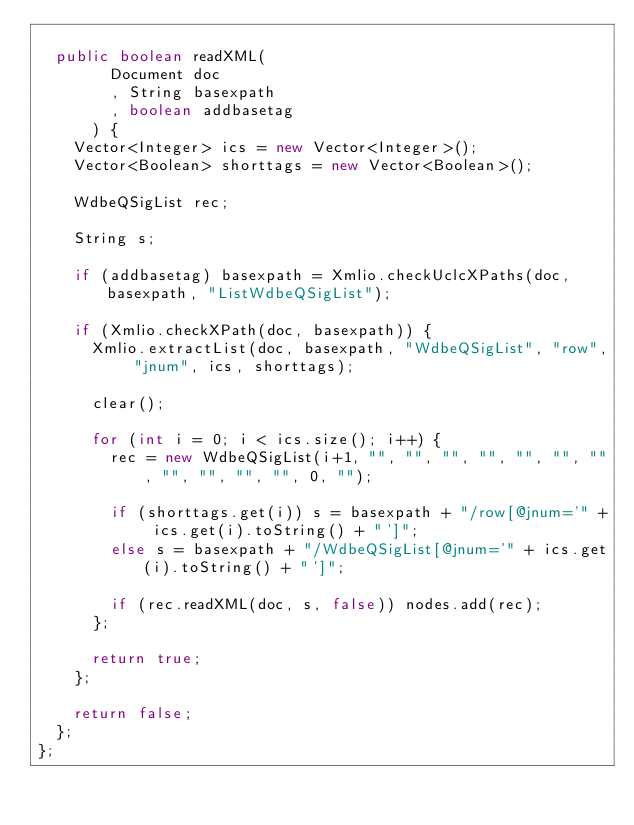Convert code to text. <code><loc_0><loc_0><loc_500><loc_500><_Java_>
	public boolean readXML(
				Document doc
				, String basexpath
				, boolean addbasetag
			) {
		Vector<Integer> ics = new Vector<Integer>();
		Vector<Boolean> shorttags = new Vector<Boolean>();

		WdbeQSigList rec;

		String s;

		if (addbasetag) basexpath = Xmlio.checkUclcXPaths(doc, basexpath, "ListWdbeQSigList");

		if (Xmlio.checkXPath(doc, basexpath)) {
			Xmlio.extractList(doc, basexpath, "WdbeQSigList", "row", "jnum", ics, shorttags);

			clear();
			
			for (int i = 0; i < ics.size(); i++) {
				rec = new WdbeQSigList(i+1, "", "", "", "", "", "", "", "", "", "", "", 0, "");

				if (shorttags.get(i)) s = basexpath + "/row[@jnum='" + ics.get(i).toString() + "']";
				else s = basexpath + "/WdbeQSigList[@jnum='" + ics.get(i).toString() + "']";
				
				if (rec.readXML(doc, s, false)) nodes.add(rec);
			};
			
			return true;
		};

		return false;
	};
};
</code> 